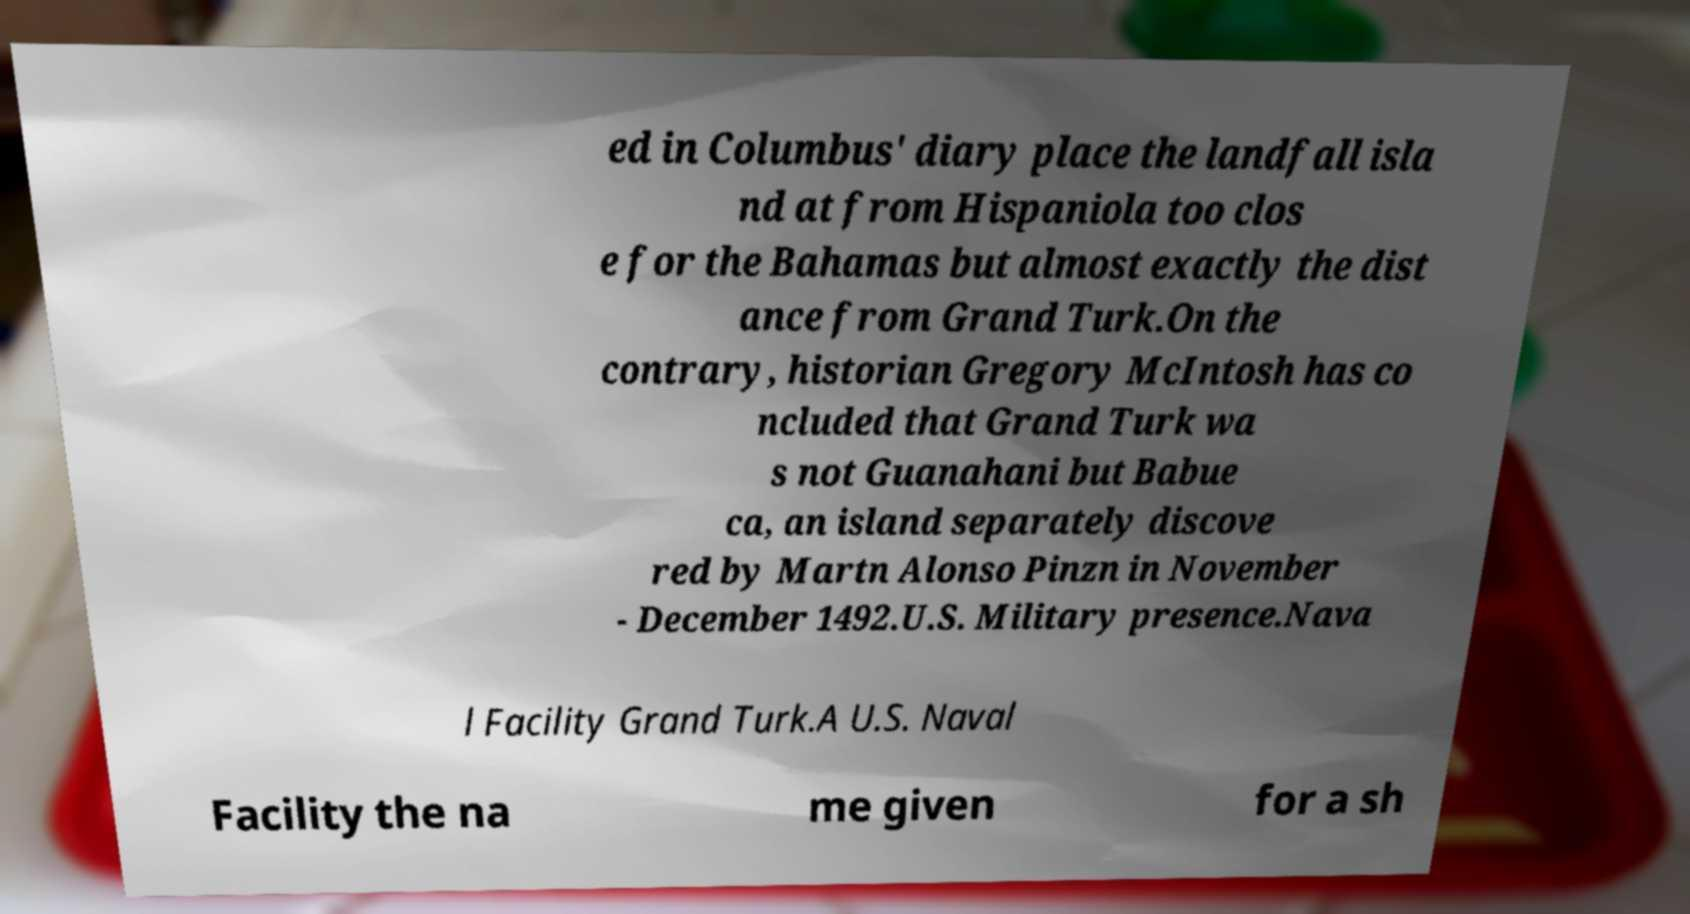I need the written content from this picture converted into text. Can you do that? ed in Columbus' diary place the landfall isla nd at from Hispaniola too clos e for the Bahamas but almost exactly the dist ance from Grand Turk.On the contrary, historian Gregory McIntosh has co ncluded that Grand Turk wa s not Guanahani but Babue ca, an island separately discove red by Martn Alonso Pinzn in November - December 1492.U.S. Military presence.Nava l Facility Grand Turk.A U.S. Naval Facility the na me given for a sh 